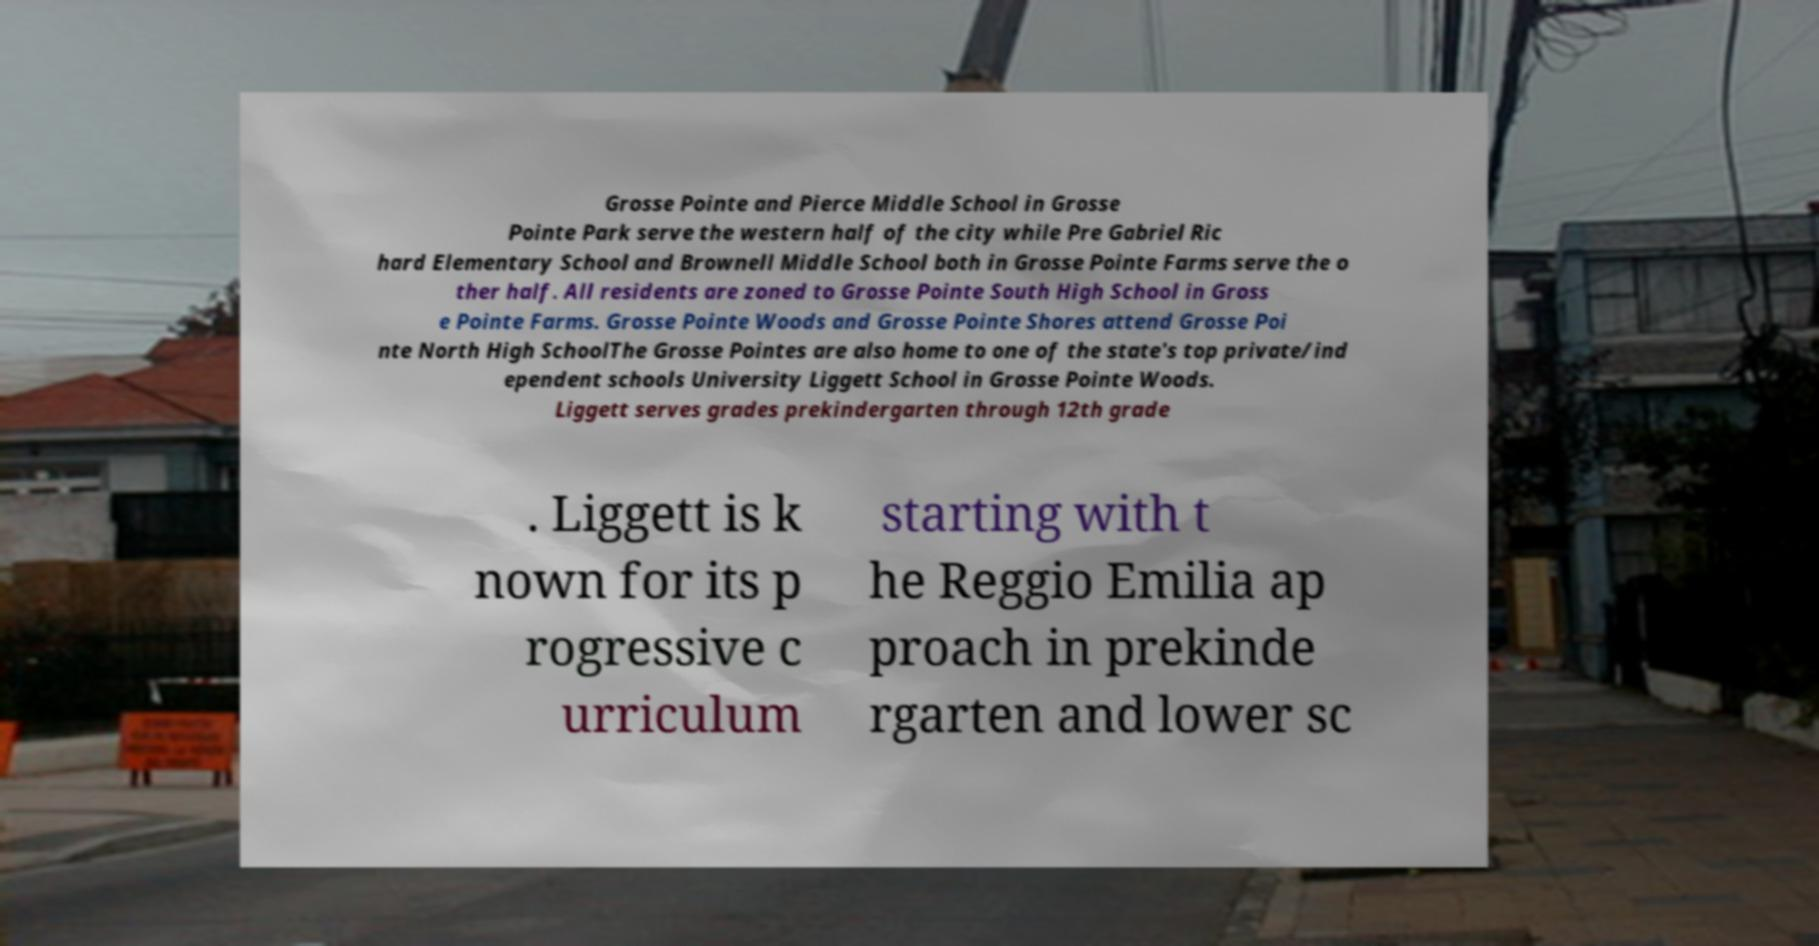Can you accurately transcribe the text from the provided image for me? Grosse Pointe and Pierce Middle School in Grosse Pointe Park serve the western half of the city while Pre Gabriel Ric hard Elementary School and Brownell Middle School both in Grosse Pointe Farms serve the o ther half. All residents are zoned to Grosse Pointe South High School in Gross e Pointe Farms. Grosse Pointe Woods and Grosse Pointe Shores attend Grosse Poi nte North High SchoolThe Grosse Pointes are also home to one of the state's top private/ind ependent schools University Liggett School in Grosse Pointe Woods. Liggett serves grades prekindergarten through 12th grade . Liggett is k nown for its p rogressive c urriculum starting with t he Reggio Emilia ap proach in prekinde rgarten and lower sc 